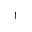<formula> <loc_0><loc_0><loc_500><loc_500>1</formula> 